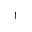<formula> <loc_0><loc_0><loc_500><loc_500>1</formula> 